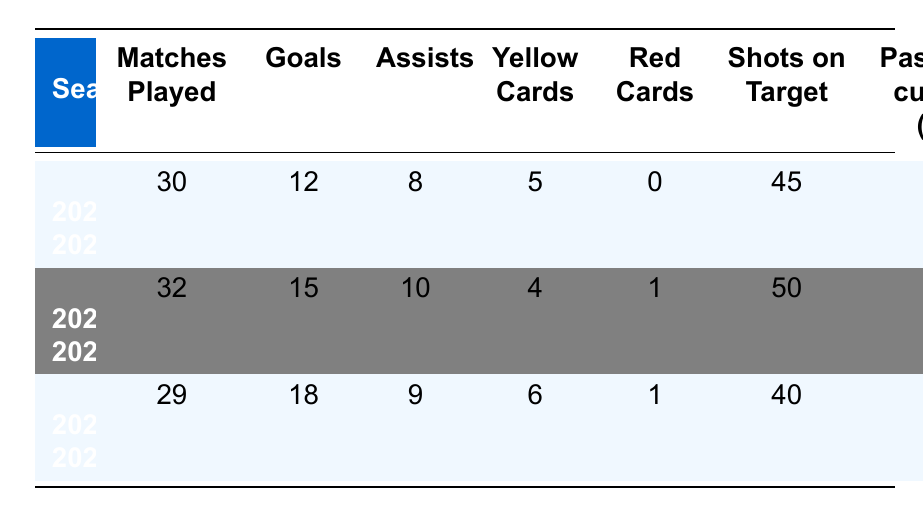What is Armand Moradi's highest number of goals scored in a season? In the table, the goals scored by Armand Moradi for each season are as follows: 12 in the 2020-2021 season, 15 in the 2021-2022 season, and 18 in the 2022-2023 season. The highest value among these is 18.
Answer: 18 How many matches did Armand Moradi play in total across all three seasons? To find the total matches played, we sum the matches from each season: 30 (2020-2021) + 32 (2021-2022) + 29 (2022-2023) = 91.
Answer: 91 Did Armand Moradi receive more yellow cards in the 2022-2023 season compared to the previous season? In the 2021-2022 season, he received 4 yellow cards, while in the 2022-2023 season, he received 6 yellow cards. Since 6 is greater than 4, the answer is yes.
Answer: Yes What is the difference in assists between the 2021-2022 and 2022-2023 seasons? In the 2021-2022 season, he had 10 assists, and in the 2022-2023 season, he had 9 assists. To find the difference, we calculate 10 - 9 = 1.
Answer: 1 What was Armand Moradi's average pass accuracy over the three seasons? The pass accuracies for the three seasons are 82%, 85%, and 80%. To find the average, add these values (82 + 85 + 80 = 247) and divide by the number of seasons (247 / 3 ≈ 82.33).
Answer: 82.33 